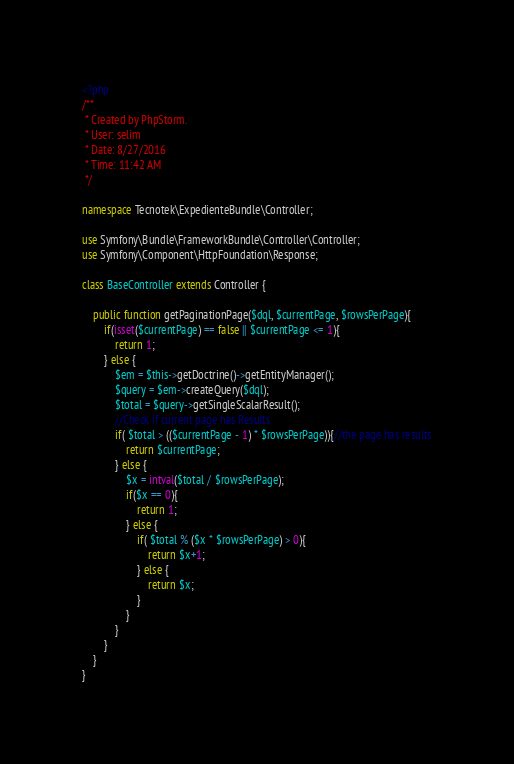Convert code to text. <code><loc_0><loc_0><loc_500><loc_500><_PHP_><?php
/**
 * Created by PhpStorm.
 * User: selim
 * Date: 8/27/2016
 * Time: 11:42 AM
 */

namespace Tecnotek\ExpedienteBundle\Controller;

use Symfony\Bundle\FrameworkBundle\Controller\Controller;
use Symfony\Component\HttpFoundation\Response;

class BaseController extends Controller {

    public function getPaginationPage($dql, $currentPage, $rowsPerPage){
        if(isset($currentPage) == false || $currentPage <= 1){
            return 1;
        } else {
            $em = $this->getDoctrine()->getEntityManager();
            $query = $em->createQuery($dql);
            $total = $query->getSingleScalarResult();
            //Check if current page has Results
            if( $total > (($currentPage - 1) * $rowsPerPage)){//the page has results
                return $currentPage;
            } else {
                $x = intval($total / $rowsPerPage);
                if($x == 0){
                    return 1;
                } else {
                    if( $total % ($x * $rowsPerPage) > 0){
                        return $x+1;
                    } else {
                        return $x;
                    }
                }
            }
        }
    }
}</code> 